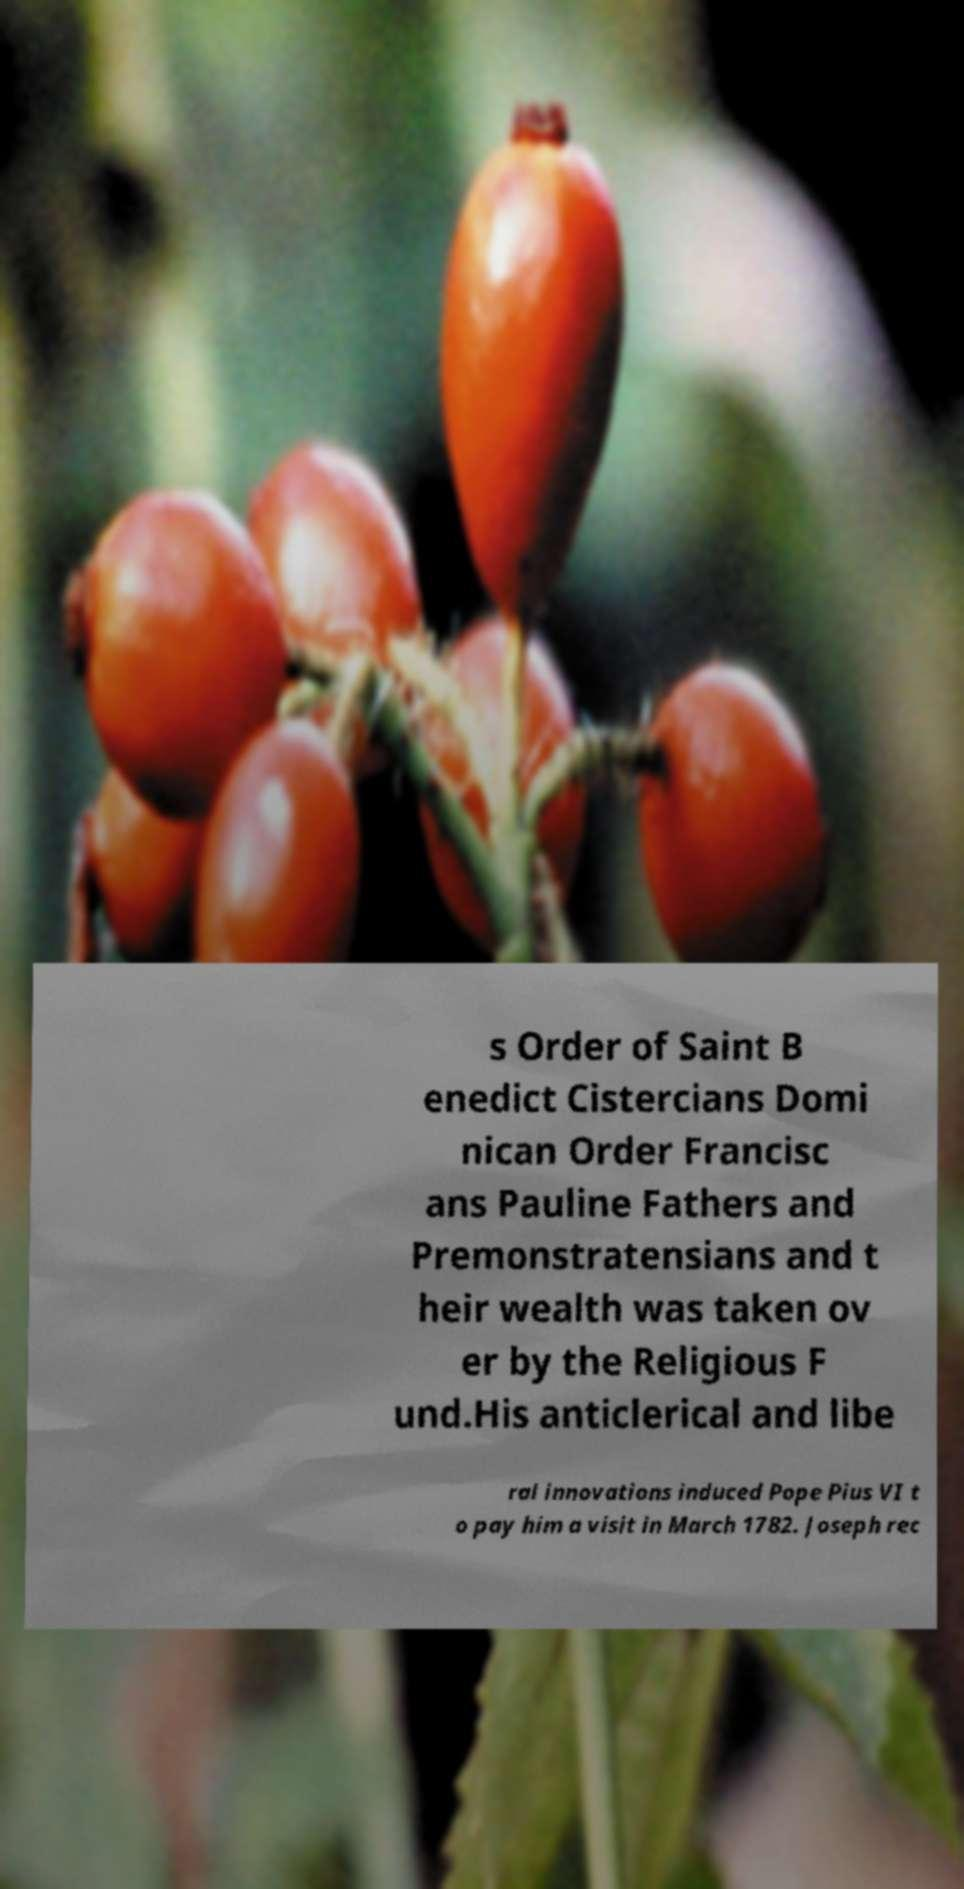There's text embedded in this image that I need extracted. Can you transcribe it verbatim? s Order of Saint B enedict Cistercians Domi nican Order Francisc ans Pauline Fathers and Premonstratensians and t heir wealth was taken ov er by the Religious F und.His anticlerical and libe ral innovations induced Pope Pius VI t o pay him a visit in March 1782. Joseph rec 